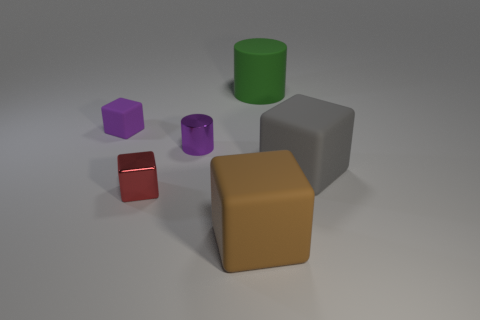Can you describe the light source in the image? The image is lit in a manner suggesting an overhead, diffused light source, given the soft shadows cast by the objects on the ground. Subtle highlights on the objects' edges further indicate the softness of the light, typical of a studio lighting setup. 